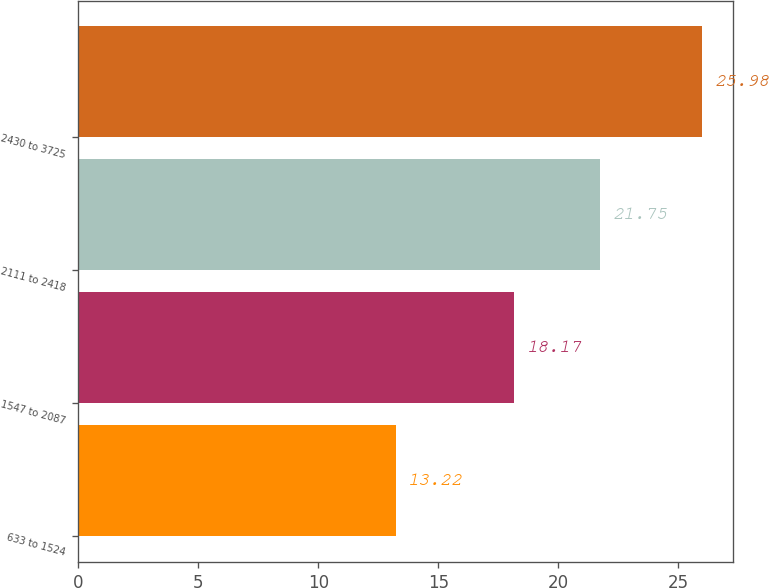Convert chart. <chart><loc_0><loc_0><loc_500><loc_500><bar_chart><fcel>633 to 1524<fcel>1547 to 2087<fcel>2111 to 2418<fcel>2430 to 3725<nl><fcel>13.22<fcel>18.17<fcel>21.75<fcel>25.98<nl></chart> 